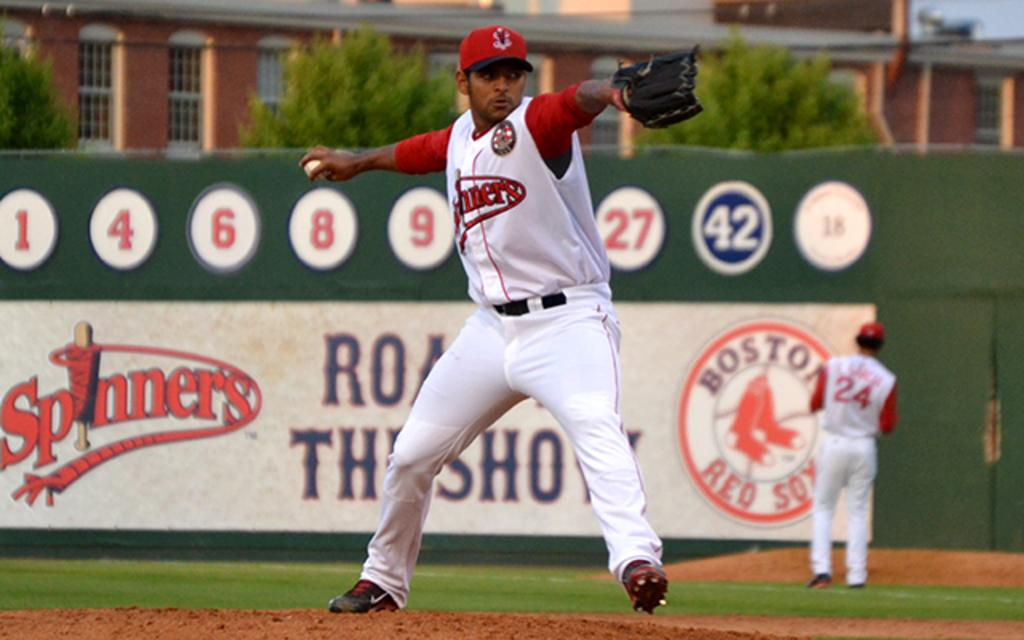<image>
Summarize the visual content of the image. A man in a spinners baseball uniform gets ready to throw the ball. 